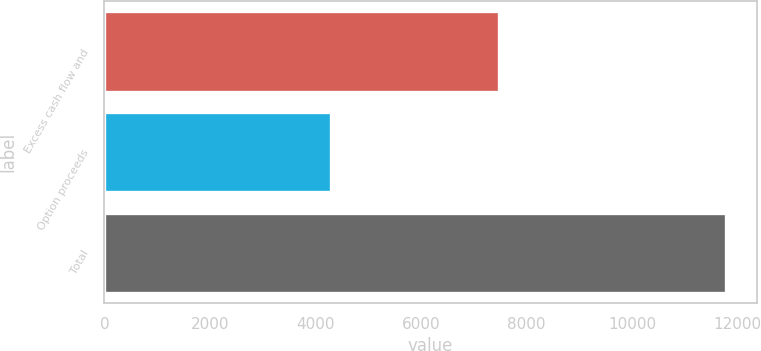Convert chart to OTSL. <chart><loc_0><loc_0><loc_500><loc_500><bar_chart><fcel>Excess cash flow and<fcel>Option proceeds<fcel>Total<nl><fcel>7479<fcel>4292<fcel>11771<nl></chart> 